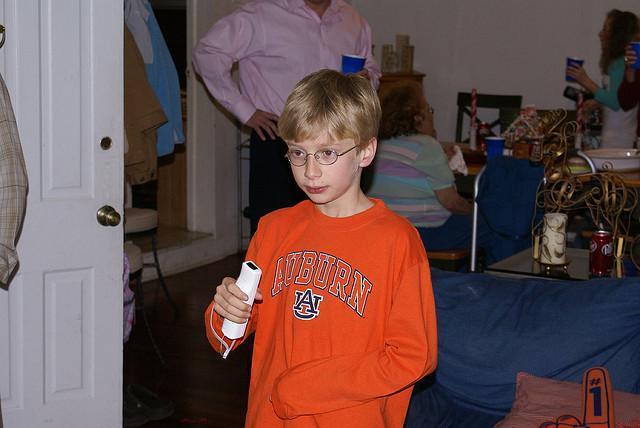How many chairs are in the photo?
Give a very brief answer. 3. How many people are in the picture?
Give a very brief answer. 5. 